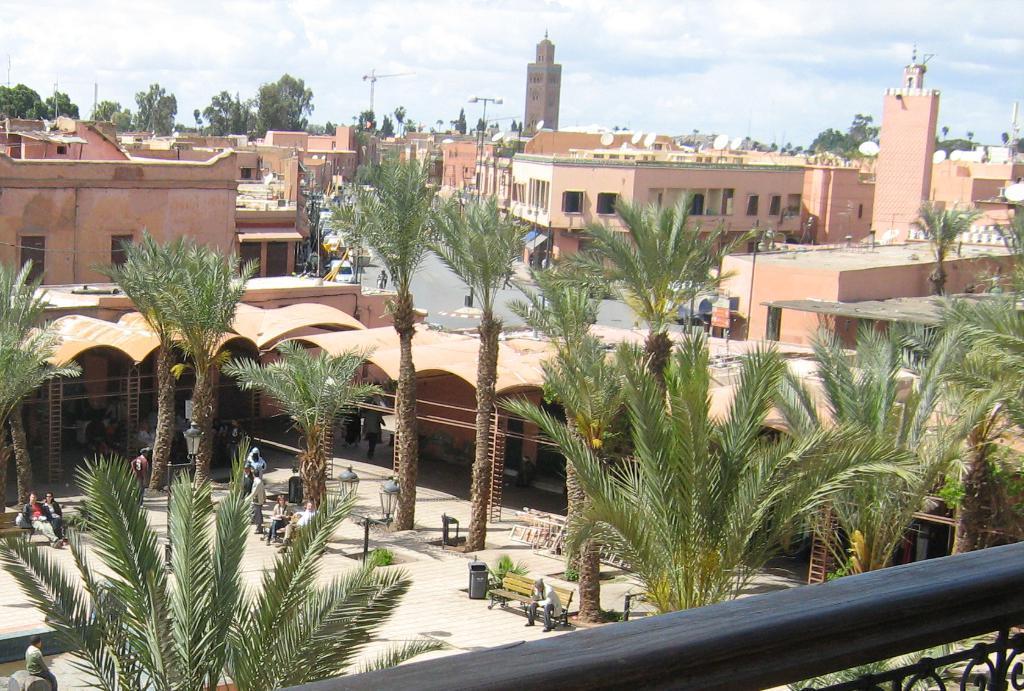Describe this image in one or two sentences. In this picture I can see a black color thing in front and in the middle of this picture I see number of buildings and trees and I see few people on the path and I see few cars on the road. In the background I see the sky. 